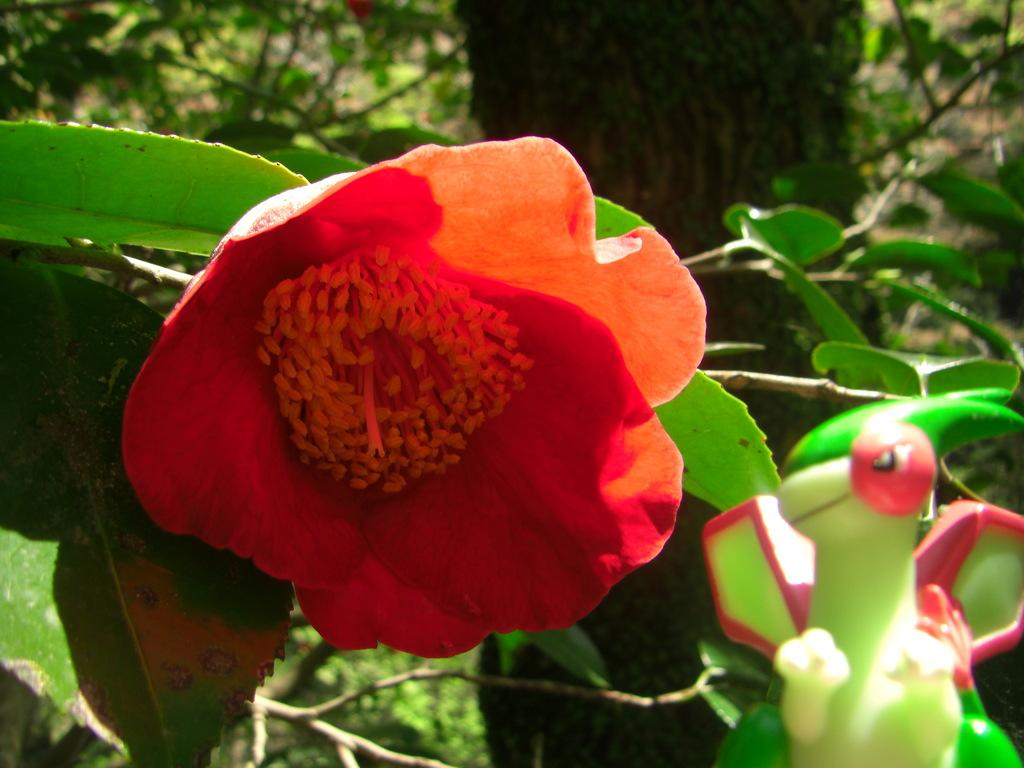What is the main subject of the image? There is a flower in the image. What is located behind the flower? There are leaves behind the flower. What is located even further behind the flower and leaves? There is a tree behind the flower and leaves. What type of road can be seen in the image? There is no road present in the image; it features a flower, leaves, and a tree. How many street signs are visible in the image? There are no street signs present in the image. 